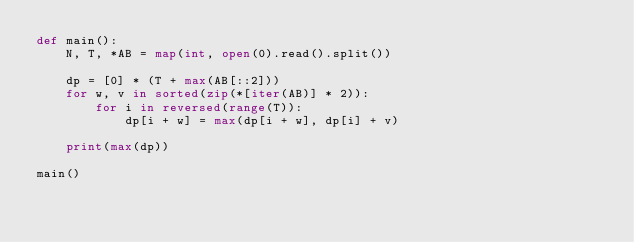Convert code to text. <code><loc_0><loc_0><loc_500><loc_500><_Python_>def main():
    N, T, *AB = map(int, open(0).read().split())

    dp = [0] * (T + max(AB[::2]))
    for w, v in sorted(zip(*[iter(AB)] * 2)):
        for i in reversed(range(T)):
            dp[i + w] = max(dp[i + w], dp[i] + v)

    print(max(dp))

main()</code> 